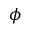<formula> <loc_0><loc_0><loc_500><loc_500>\phi</formula> 